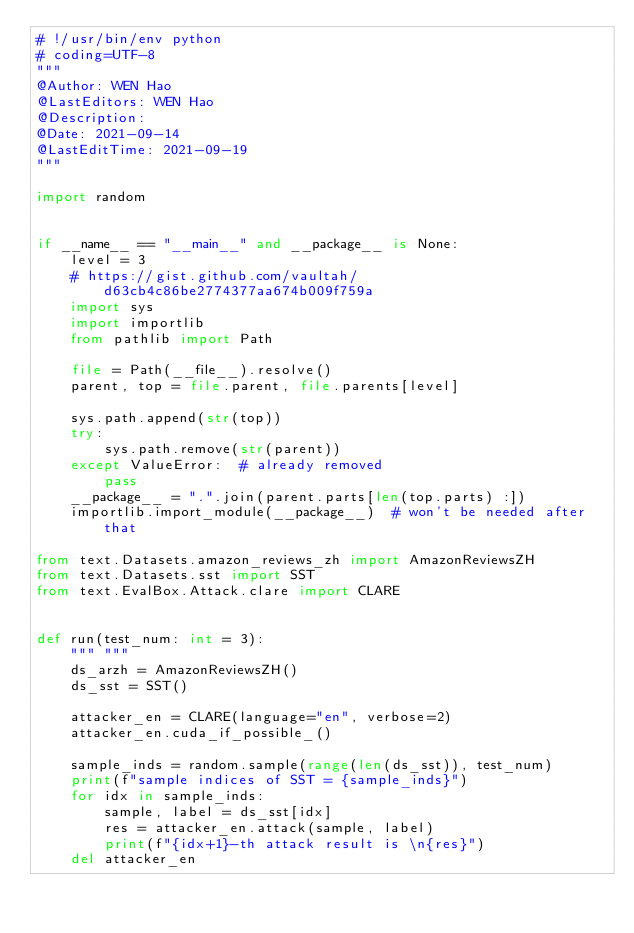<code> <loc_0><loc_0><loc_500><loc_500><_Python_># !/usr/bin/env python
# coding=UTF-8
"""
@Author: WEN Hao
@LastEditors: WEN Hao
@Description:
@Date: 2021-09-14
@LastEditTime: 2021-09-19
"""

import random


if __name__ == "__main__" and __package__ is None:
    level = 3
    # https://gist.github.com/vaultah/d63cb4c86be2774377aa674b009f759a
    import sys
    import importlib
    from pathlib import Path

    file = Path(__file__).resolve()
    parent, top = file.parent, file.parents[level]

    sys.path.append(str(top))
    try:
        sys.path.remove(str(parent))
    except ValueError:  # already removed
        pass
    __package__ = ".".join(parent.parts[len(top.parts) :])
    importlib.import_module(__package__)  # won't be needed after that

from text.Datasets.amazon_reviews_zh import AmazonReviewsZH
from text.Datasets.sst import SST
from text.EvalBox.Attack.clare import CLARE


def run(test_num: int = 3):
    """ """
    ds_arzh = AmazonReviewsZH()
    ds_sst = SST()

    attacker_en = CLARE(language="en", verbose=2)
    attacker_en.cuda_if_possible_()

    sample_inds = random.sample(range(len(ds_sst)), test_num)
    print(f"sample indices of SST = {sample_inds}")
    for idx in sample_inds:
        sample, label = ds_sst[idx]
        res = attacker_en.attack(sample, label)
        print(f"{idx+1}-th attack result is \n{res}")
    del attacker_en
</code> 